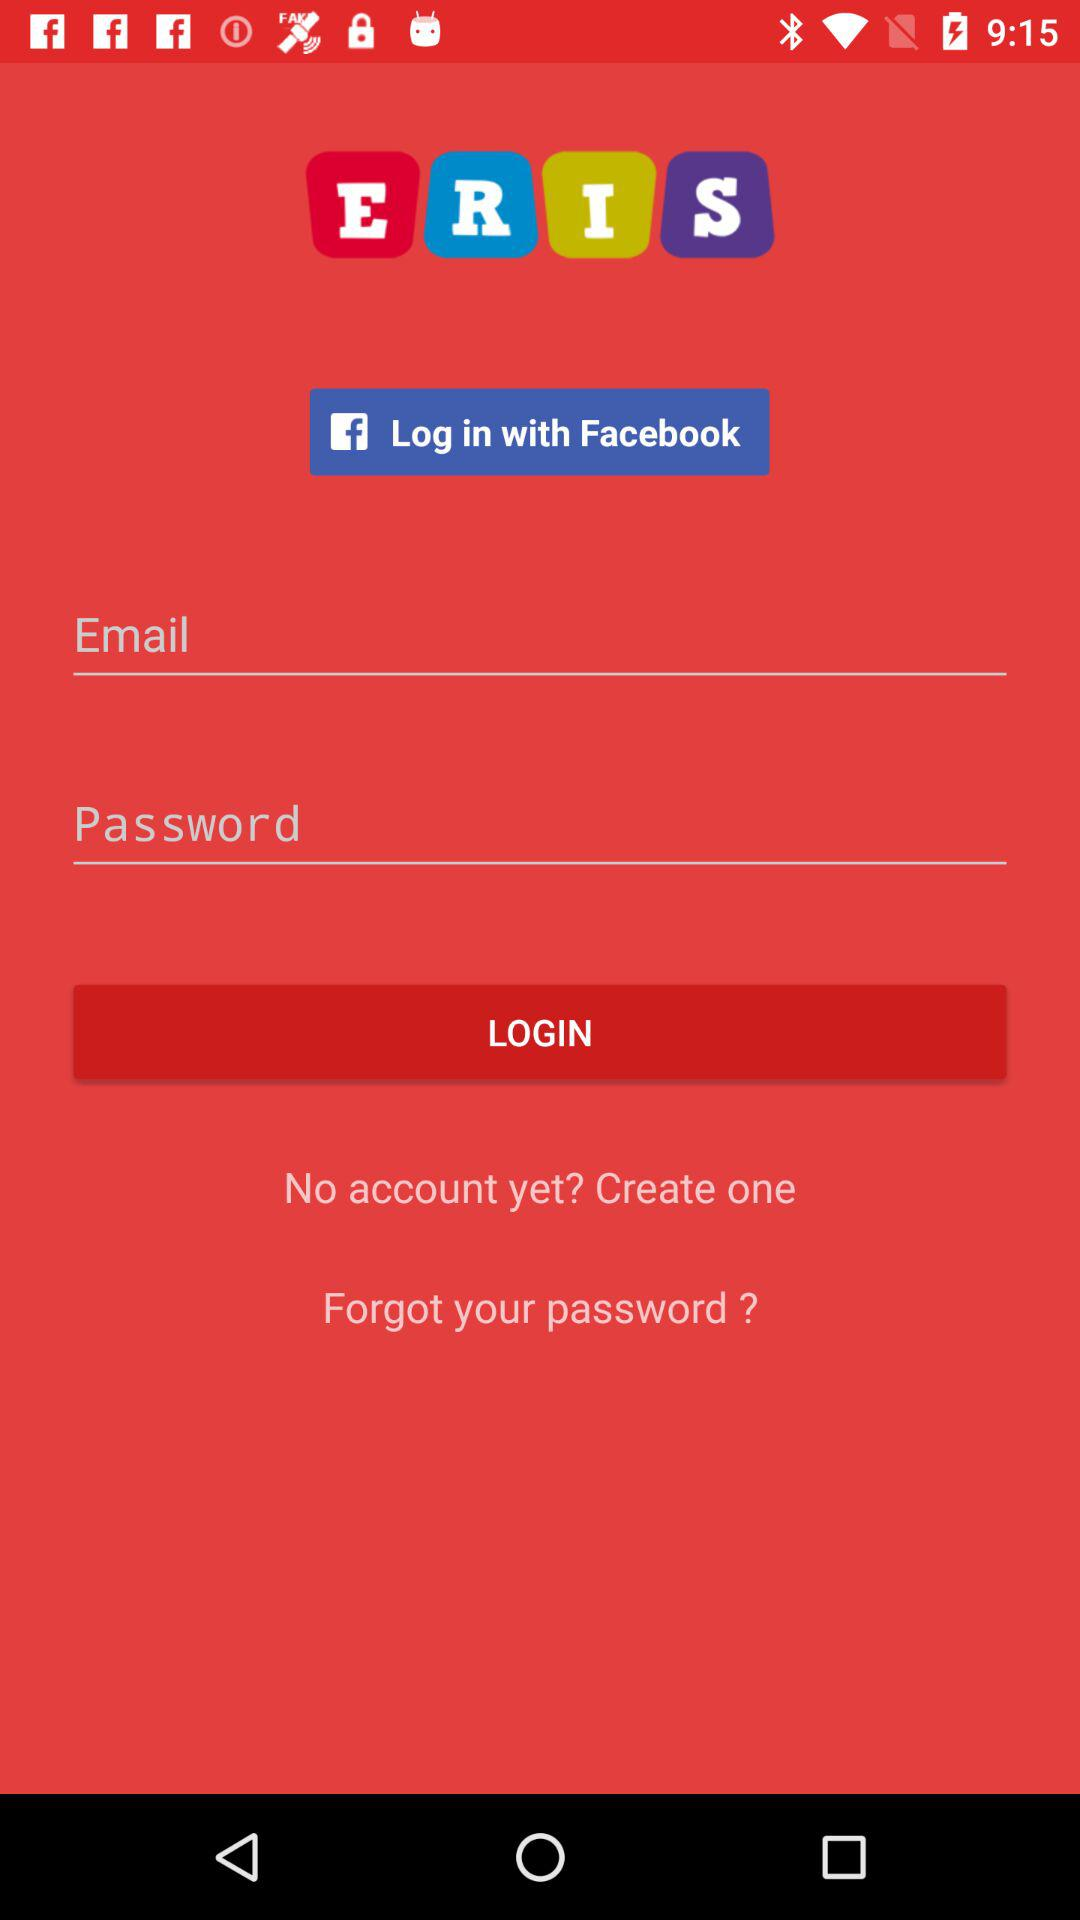What are the requirements to log in? The requirements to log in are "Email" and "Password". 